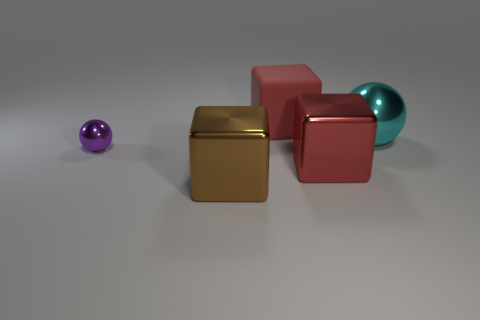Is there any other thing that is the same material as the big brown cube?
Your answer should be compact. Yes. What number of other objects are the same shape as the cyan object?
Your answer should be compact. 1. What number of big red blocks are behind the big red block to the right of the large object behind the cyan thing?
Provide a short and direct response. 1. What number of red things are the same shape as the cyan object?
Keep it short and to the point. 0. Is the color of the large cube behind the large cyan object the same as the small metal ball?
Your response must be concise. No. What is the shape of the red thing that is to the left of the big block that is right of the red object that is behind the tiny shiny sphere?
Ensure brevity in your answer.  Cube. Do the brown thing and the red cube that is in front of the big red rubber thing have the same size?
Keep it short and to the point. Yes. Are there any cyan rubber cylinders that have the same size as the brown metal thing?
Offer a very short reply. No. How many other things are the same material as the small ball?
Provide a succinct answer. 3. The large block that is both behind the large brown metal thing and in front of the big sphere is what color?
Offer a very short reply. Red. 